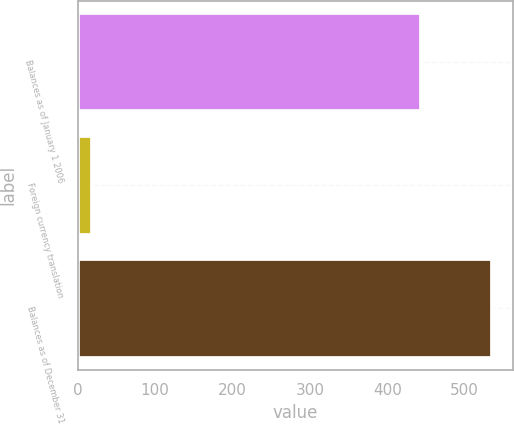Convert chart to OTSL. <chart><loc_0><loc_0><loc_500><loc_500><bar_chart><fcel>Balances as of January 1 2006<fcel>Foreign currency translation<fcel>Balances as of December 31<nl><fcel>444.2<fcel>18<fcel>536.08<nl></chart> 